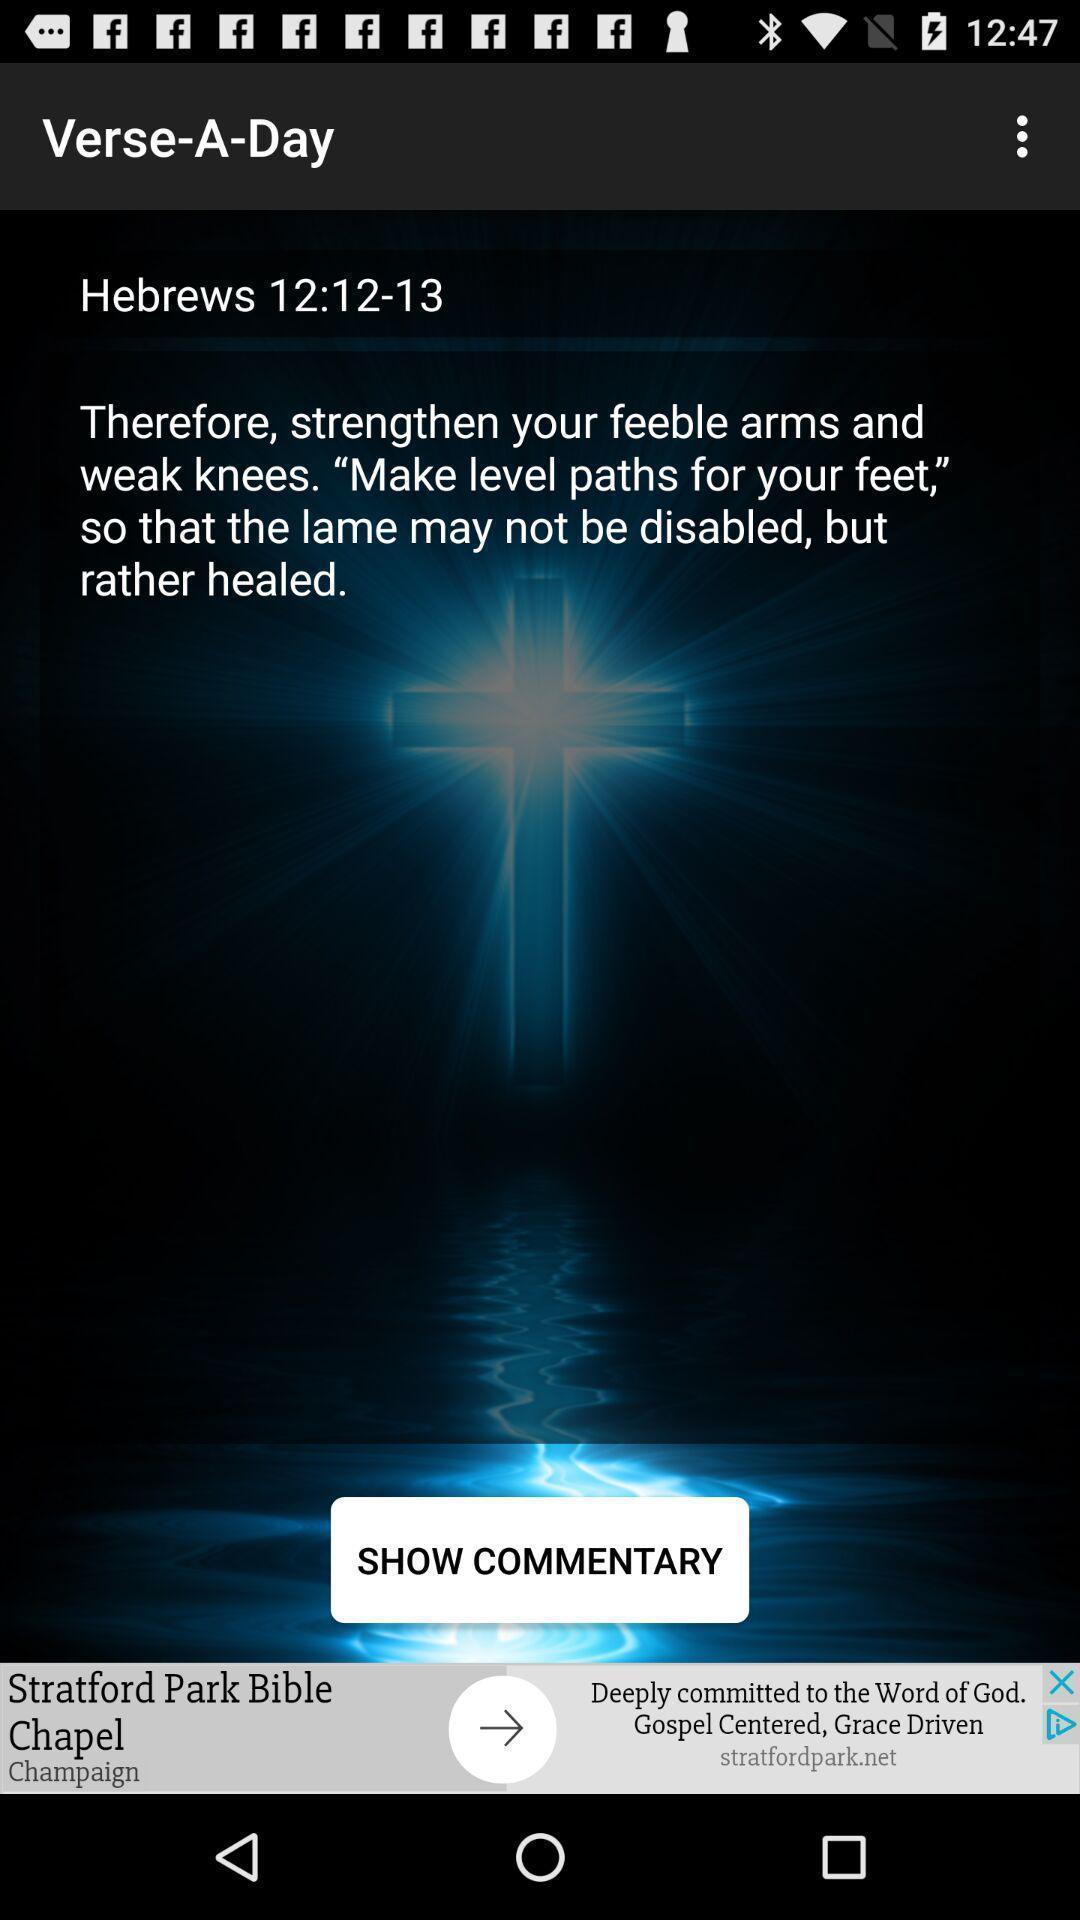Provide a detailed account of this screenshot. Screen shows a verse from a holy scripture. 